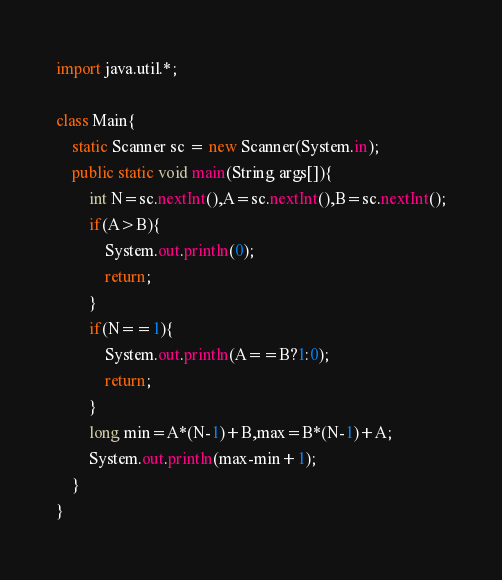Convert code to text. <code><loc_0><loc_0><loc_500><loc_500><_Java_>import java.util.*;

class Main{
    static Scanner sc = new Scanner(System.in);
    public static void main(String args[]){
        int N=sc.nextInt(),A=sc.nextInt(),B=sc.nextInt();
        if(A>B){
            System.out.println(0);
            return;
        }
        if(N==1){
            System.out.println(A==B?1:0);
            return;
        }
        long min=A*(N-1)+B,max=B*(N-1)+A;
        System.out.println(max-min+1);
    }
}</code> 